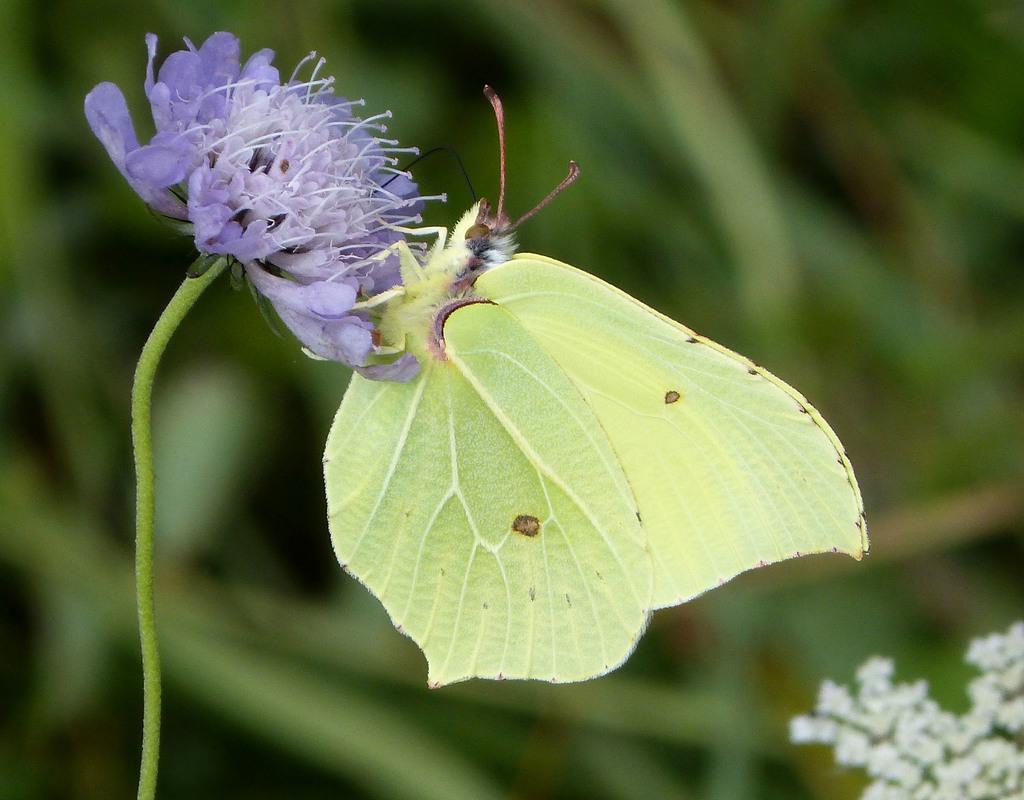Please provide a concise description of this image. In this picture, we see a butterfly in yellow color is on the violet flower. In the right bottom of the picture, we see flowers and these flowers are in white color. In the background, it is green in color. This picture is blurred in the background. 